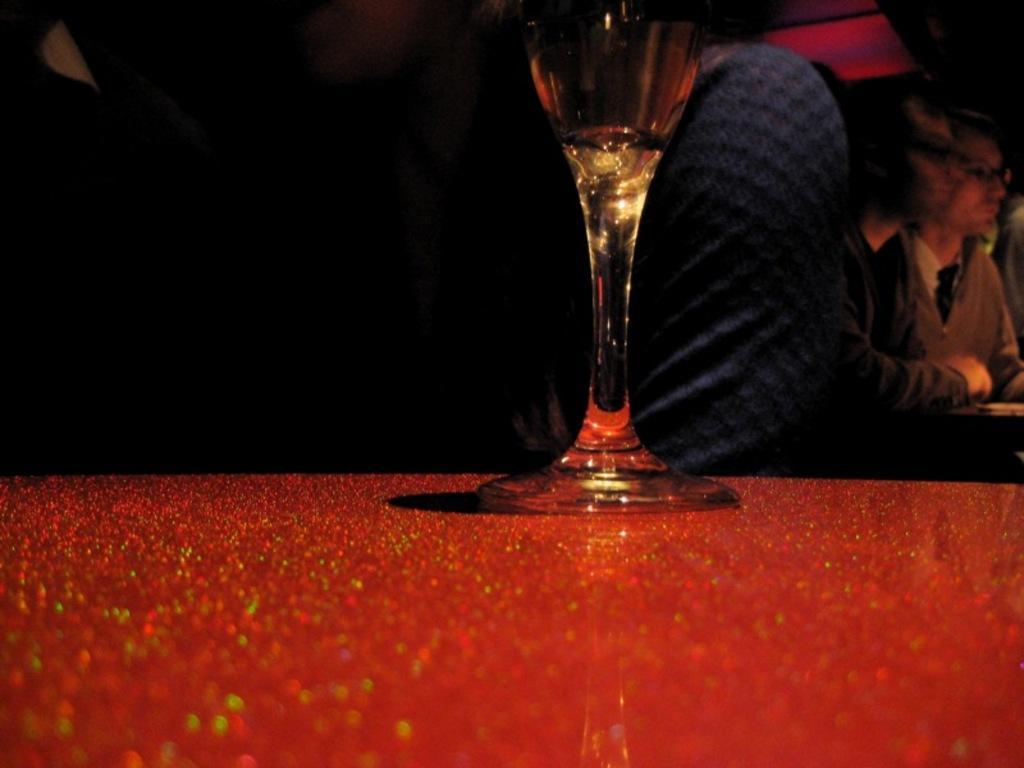How would you summarize this image in a sentence or two? Here we have a glass of wine kept on a red shiny table. In the background we can see people sitting. 